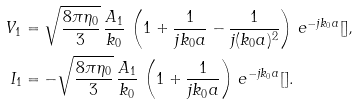<formula> <loc_0><loc_0><loc_500><loc_500>V _ { 1 } & = \sqrt { \frac { 8 \pi \eta _ { 0 } } { 3 } } \, \frac { A _ { 1 } } { k _ { 0 } } \, \left ( 1 + \frac { 1 } { j k _ { 0 } a } - \frac { 1 } { j ( k _ { 0 } a ) ^ { 2 } } \right ) \, e ^ { - j k _ { 0 } a } [ ] , \\ I _ { 1 } & = - \sqrt { \frac { 8 \pi \eta _ { 0 } } { 3 } } \, \frac { A _ { 1 } } { k _ { 0 } } \, \left ( 1 + \frac { 1 } { j k _ { 0 } a } \right ) \, e ^ { - j k _ { 0 } a } [ ] .</formula> 